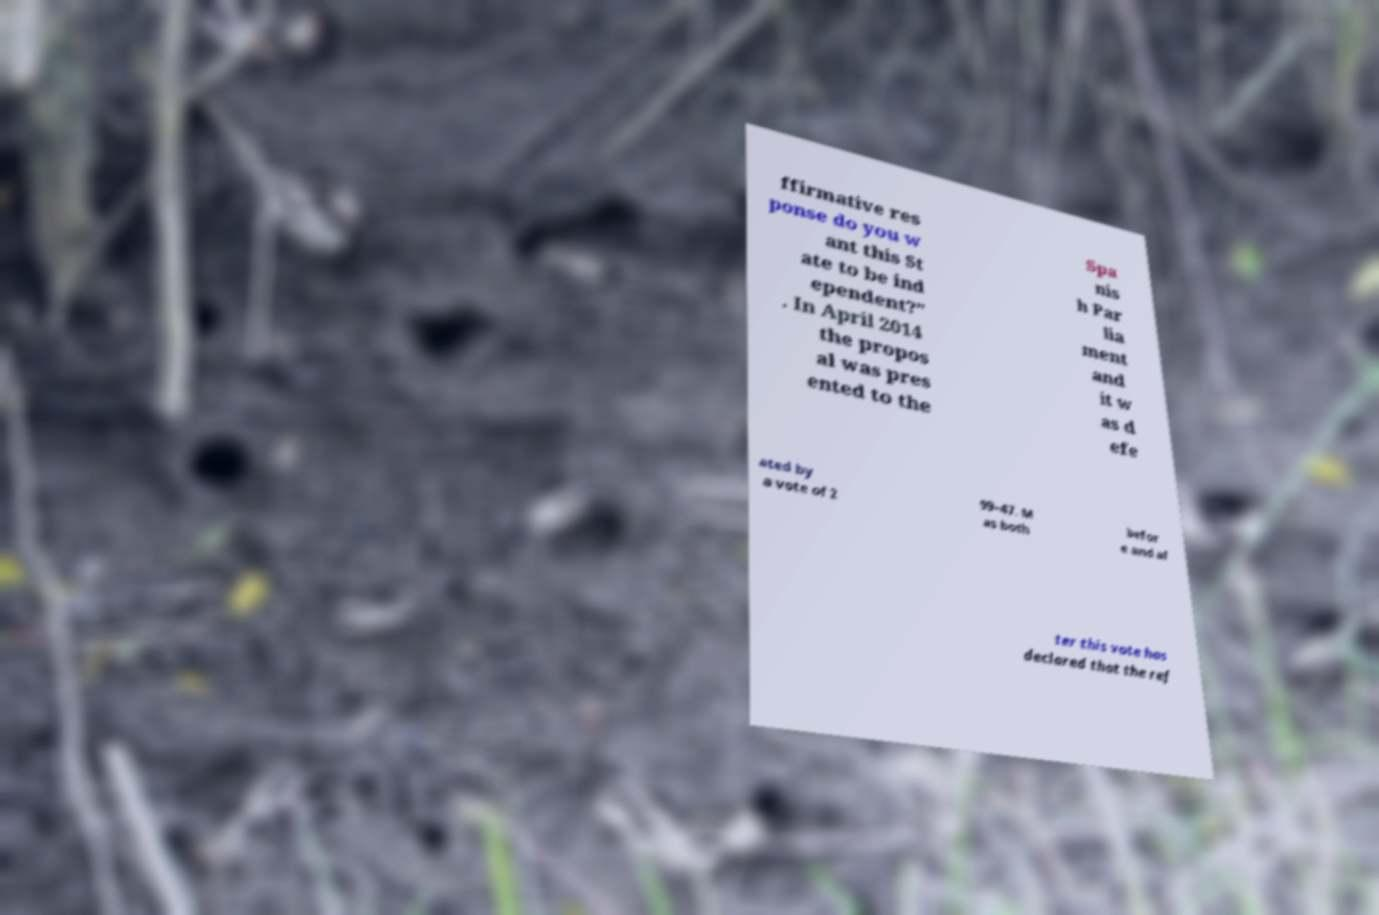Could you extract and type out the text from this image? ffirmative res ponse do you w ant this St ate to be ind ependent?" . In April 2014 the propos al was pres ented to the Spa nis h Par lia ment and it w as d efe ated by a vote of 2 99–47. M as both befor e and af ter this vote has declared that the ref 